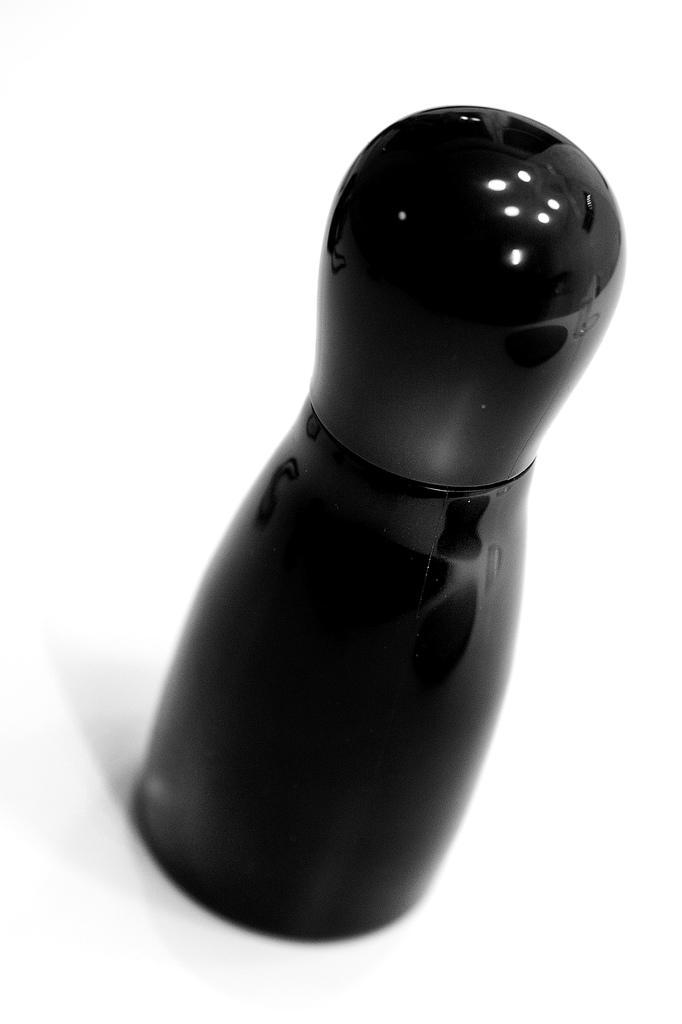Describe this image in one or two sentences. In this image we can see black color bottle. 